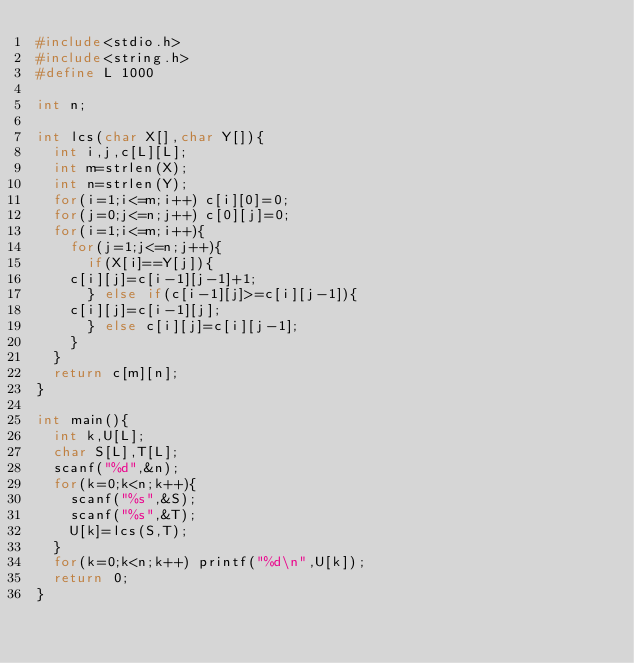<code> <loc_0><loc_0><loc_500><loc_500><_C_>#include<stdio.h>
#include<string.h>
#define L 1000

int n;

int lcs(char X[],char Y[]){
  int i,j,c[L][L];
  int m=strlen(X);
  int n=strlen(Y);
  for(i=1;i<=m;i++) c[i][0]=0;
  for(j=0;j<=n;j++) c[0][j]=0;
  for(i=1;i<=m;i++){
    for(j=1;j<=n;j++){
      if(X[i]==Y[j]){
	c[i][j]=c[i-1][j-1]+1;
      } else if(c[i-1][j]>=c[i][j-1]){
	c[i][j]=c[i-1][j];
      } else c[i][j]=c[i][j-1];
    }
  }
  return c[m][n];
}

int main(){
  int k,U[L];
  char S[L],T[L];
  scanf("%d",&n);
  for(k=0;k<n;k++){
    scanf("%s",&S);
    scanf("%s",&T);
    U[k]=lcs(S,T);
  }
  for(k=0;k<n;k++) printf("%d\n",U[k]);
  return 0;
}</code> 